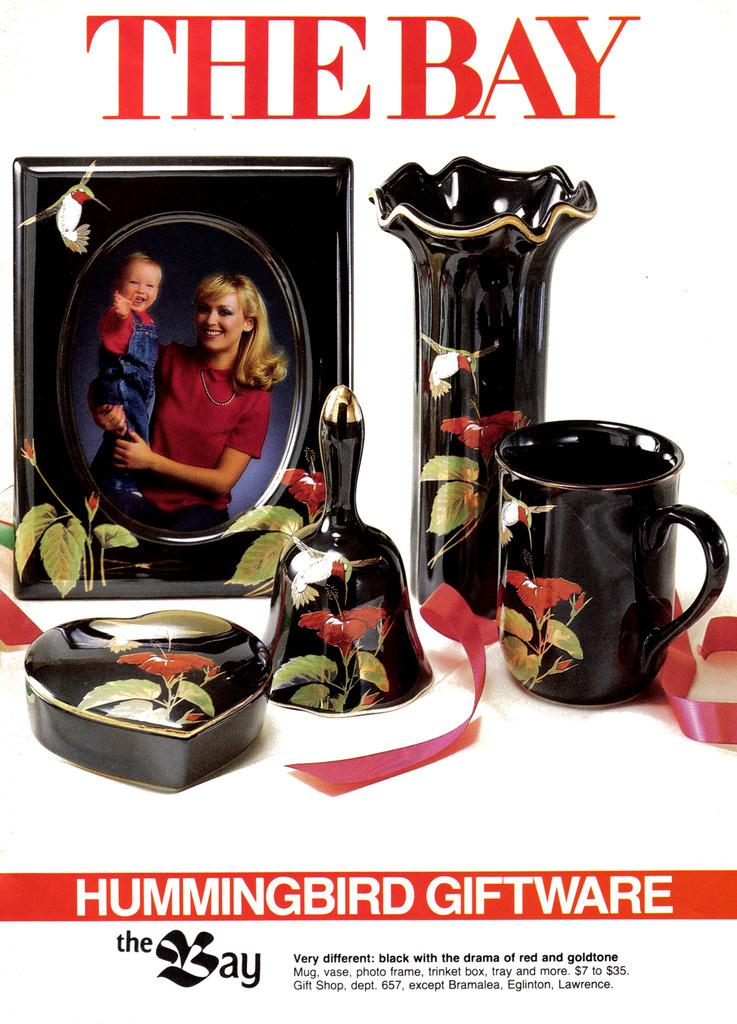<image>
Create a compact narrative representing the image presented. A display of Hummingbird Giftware that is mostly black with floral patterns. 